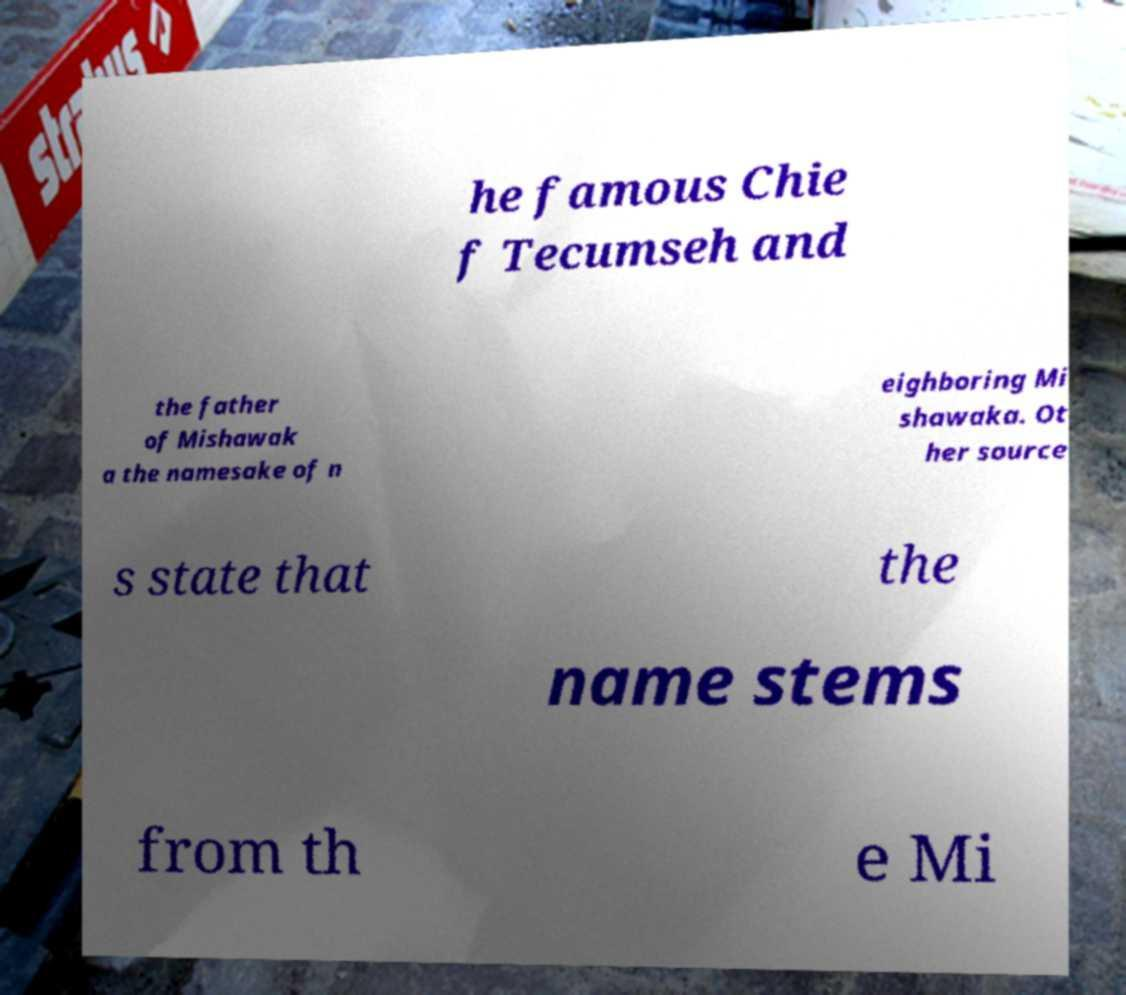Can you read and provide the text displayed in the image?This photo seems to have some interesting text. Can you extract and type it out for me? he famous Chie f Tecumseh and the father of Mishawak a the namesake of n eighboring Mi shawaka. Ot her source s state that the name stems from th e Mi 